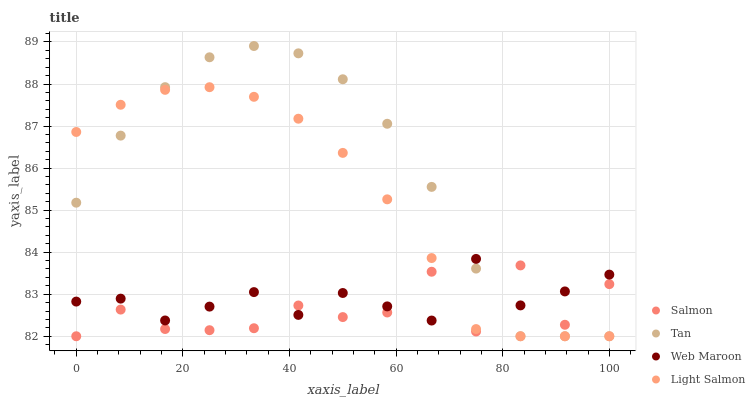Does Salmon have the minimum area under the curve?
Answer yes or no. Yes. Does Tan have the maximum area under the curve?
Answer yes or no. Yes. Does Tan have the minimum area under the curve?
Answer yes or no. No. Does Salmon have the maximum area under the curve?
Answer yes or no. No. Is Light Salmon the smoothest?
Answer yes or no. Yes. Is Salmon the roughest?
Answer yes or no. Yes. Is Tan the smoothest?
Answer yes or no. No. Is Tan the roughest?
Answer yes or no. No. Does Tan have the lowest value?
Answer yes or no. Yes. Does Tan have the highest value?
Answer yes or no. Yes. Does Salmon have the highest value?
Answer yes or no. No. Does Light Salmon intersect Salmon?
Answer yes or no. Yes. Is Light Salmon less than Salmon?
Answer yes or no. No. Is Light Salmon greater than Salmon?
Answer yes or no. No. 